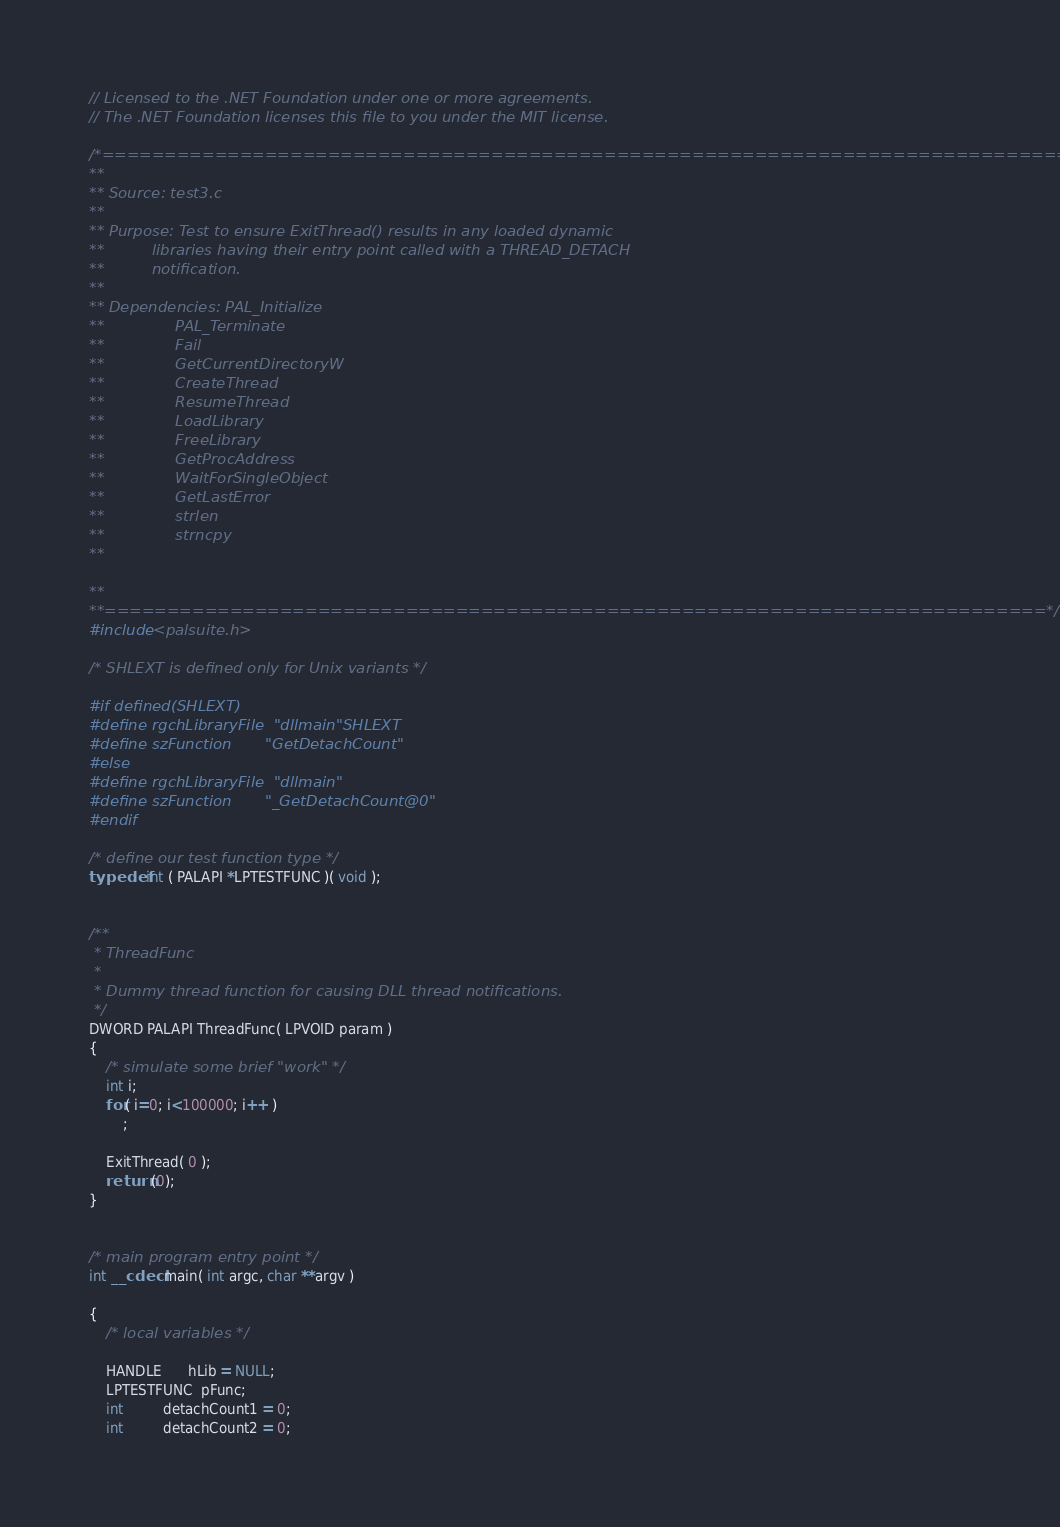<code> <loc_0><loc_0><loc_500><loc_500><_C++_>// Licensed to the .NET Foundation under one or more agreements.
// The .NET Foundation licenses this file to you under the MIT license.

/*=============================================================================
**
** Source: test3.c
**
** Purpose: Test to ensure ExitThread() results in any loaded dynamic
**          libraries having their entry point called with a THREAD_DETACH
**          notification.
** 
** Dependencies: PAL_Initialize
**               PAL_Terminate
**               Fail
**               GetCurrentDirectoryW
**               CreateThread
**               ResumeThread
**               LoadLibrary
**               FreeLibrary
**               GetProcAddress
**               WaitForSingleObject
**               GetLastError
**               strlen
**               strncpy
** 

**
**===========================================================================*/
#include <palsuite.h>

/* SHLEXT is defined only for Unix variants */

#if defined(SHLEXT)
#define rgchLibraryFile  "dllmain"SHLEXT
#define szFunction       "GetDetachCount"
#else
#define rgchLibraryFile  "dllmain"
#define szFunction       "_GetDetachCount@0"
#endif

/* define our test function type */
typedef int ( PALAPI *LPTESTFUNC )( void );


/**
 * ThreadFunc
 *
 * Dummy thread function for causing DLL thread notifications.
 */
DWORD PALAPI ThreadFunc( LPVOID param )
{
    /* simulate some brief "work" */
    int i;
    for( i=0; i<100000; i++ )
        ;
        
    ExitThread( 0 );
    return (0);
}


/* main program entry point */
int __cdecl main( int argc, char **argv ) 

{
    /* local variables */

    HANDLE      hLib = NULL;
    LPTESTFUNC  pFunc;
    int         detachCount1 = 0;
    int         detachCount2 = 0;</code> 